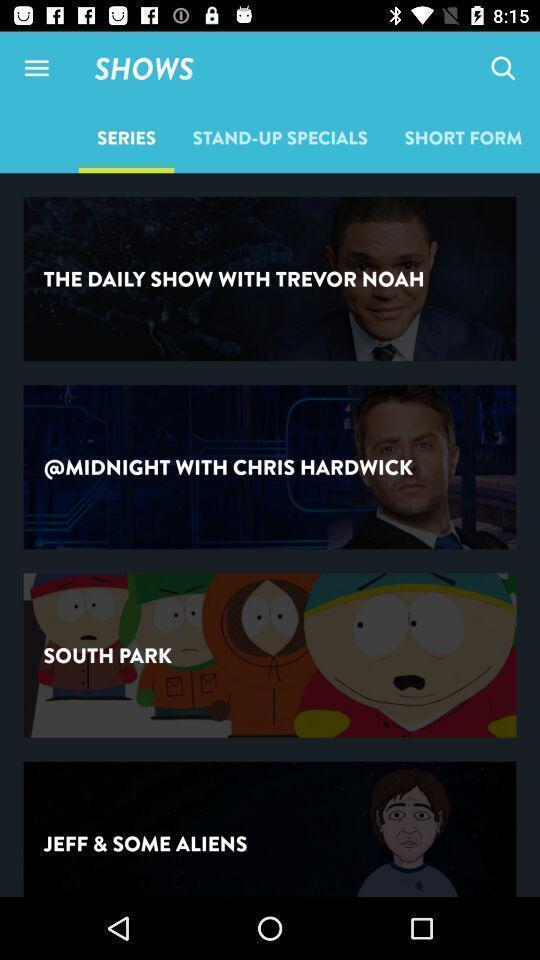Describe this image in words. Screen displaying the list of series. 